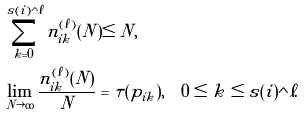Convert formula to latex. <formula><loc_0><loc_0><loc_500><loc_500>& \sum _ { k = 0 } ^ { s ( i ) \wedge \ell } n ^ { ( \ell ) } _ { i k } ( N ) \leq N , \\ & \lim _ { N \rightarrow \infty } \frac { n ^ { ( \ell ) } _ { i k } ( N ) } { N } = \tau ( p _ { i k } ) , \quad 0 \leq k \leq s ( i ) \wedge \ell .</formula> 